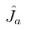Convert formula to latex. <formula><loc_0><loc_0><loc_500><loc_500>\hat { J } _ { a }</formula> 